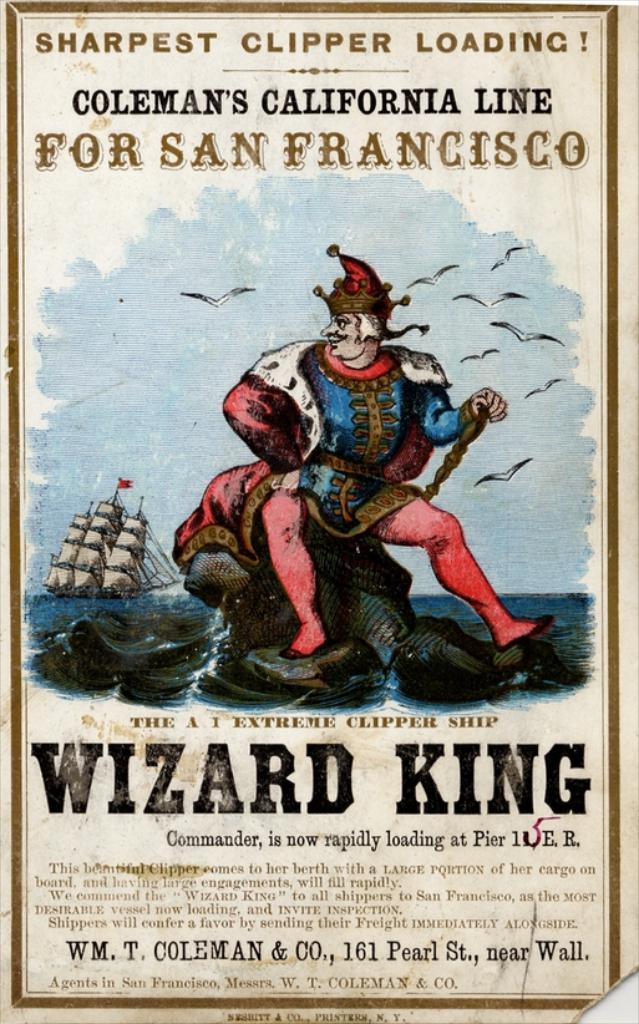Provide a one-sentence caption for the provided image. a poster that has the wizard king written on it. 